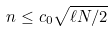Convert formula to latex. <formula><loc_0><loc_0><loc_500><loc_500>n \leq c _ { 0 } \sqrt { \ell N / 2 }</formula> 